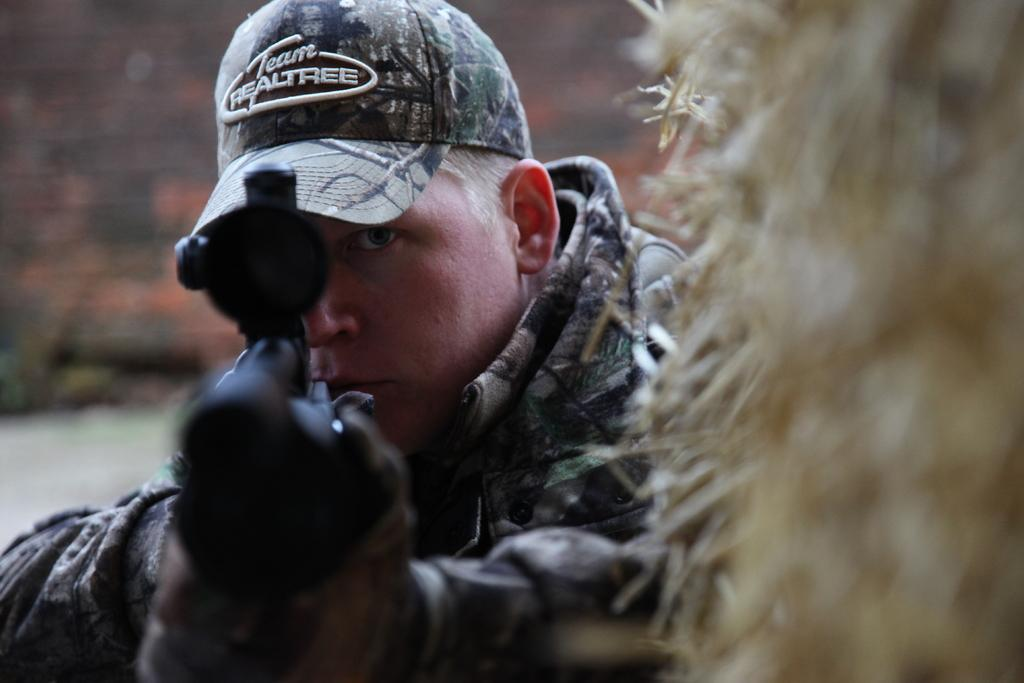What is the main subject of the image? There is a person in the image. What is the person holding in the image? The person is holding a gun. What type of headwear is the person wearing? The person is wearing a cap. What type of clothing is the person wearing? The person is wearing clothes. What type of thrill can be seen in the image? There is no indication of a thrill in the image. --- Facts: 1. There is a person in the image. 2. The person is holding a book. 3. The person is sitting on a chair. 4. The person is wearing glasses. 5. The background is a library. Absurd Topics: elephant, parrot, ocean Conversation: What is the main subject of the image? There is a person in the image. What is the person holding in the image? The person is holding a book. What is the person's position in the image? The person is sitting on a chair. What type of eyewear is the person wearing in the image? The person is wearing glasses. What can be inferred about the location of the image based on the background? The background is a library. Reasoning: Let's think step by step in order to produce the conversation. We start by identifying the main subject of the image, which is the person. Then, we describe the person's actions and accessories, such as holding a book and wearing glasses. Next, we observe the person's position in the image, which is sitting on a chair. Finally, we describe the background of the image, which is a library. Absurd Question/Answer: How many elephants and parrots can be seen in the image? There are no elephants or parrots present in the image. --- Facts: 1. There is a person in the image. 2. The person is holding a cup of coffee. 3. The person is standing near a table. 4. The person is wearing a hat. 5. The background is a café. Absurd Topics: giraffe, jungle Conversation: What is the main subject of the image? There is a person in the image. What is the person holding in the image? The person is holding a cup of coffee. What is the person's position in the image? The person is standing near a table. What type of headwear is the person wearing in the image? The person is wearing a hat. What can be inferred about the location of the image based on the background? The background is a café. Reasoning: Let's think step by step in order to produce the conversation. We start by identifying the main subject of the image, which is the person. Then, we describe the person's actions and accessories, such as holding 